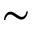Convert formula to latex. <formula><loc_0><loc_0><loc_500><loc_500>\sim</formula> 